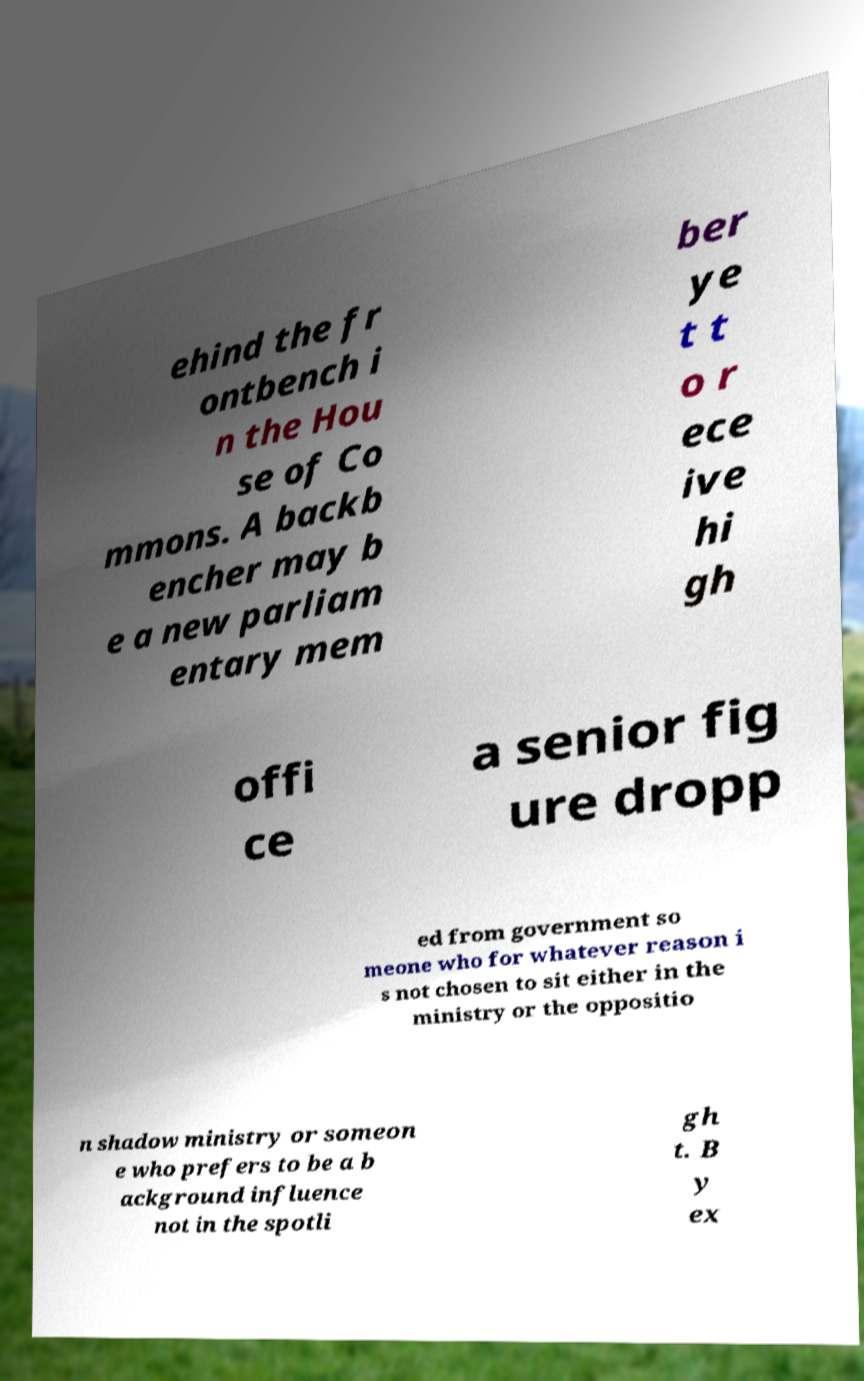Can you read and provide the text displayed in the image?This photo seems to have some interesting text. Can you extract and type it out for me? ehind the fr ontbench i n the Hou se of Co mmons. A backb encher may b e a new parliam entary mem ber ye t t o r ece ive hi gh offi ce a senior fig ure dropp ed from government so meone who for whatever reason i s not chosen to sit either in the ministry or the oppositio n shadow ministry or someon e who prefers to be a b ackground influence not in the spotli gh t. B y ex 